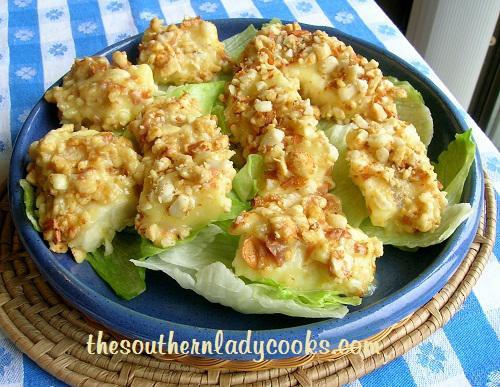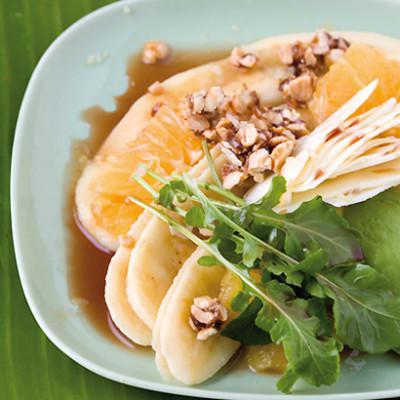The first image is the image on the left, the second image is the image on the right. Given the left and right images, does the statement "One image shows ingredients sitting on a bed of green lettuce leaves on a dish." hold true? Answer yes or no. Yes. The first image is the image on the left, the second image is the image on the right. Examine the images to the left and right. Is the description "In at least one image there is a salad on a plate with apple and sliced red onions." accurate? Answer yes or no. No. 